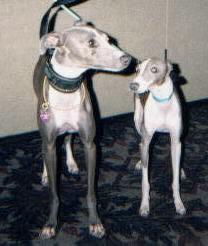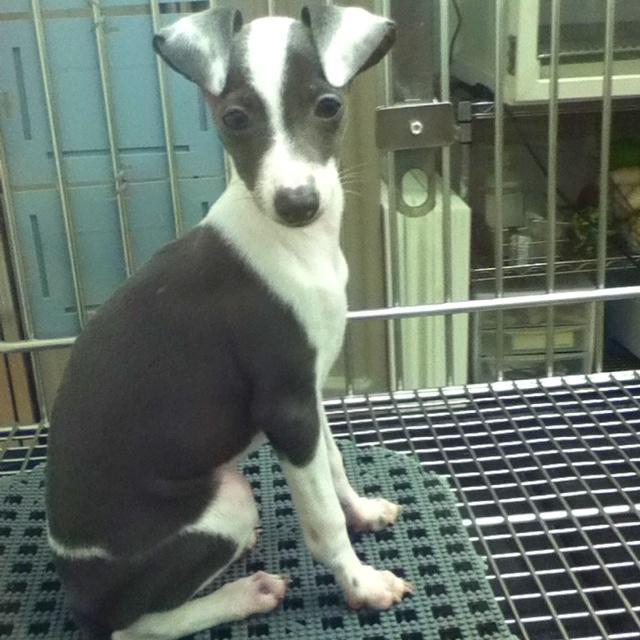The first image is the image on the left, the second image is the image on the right. For the images shown, is this caption "One image shows a dog sitting upright, and the other shows at least one dog standing on all fours." true? Answer yes or no. Yes. The first image is the image on the left, the second image is the image on the right. Assess this claim about the two images: "At least one of the dog is wearing a collar.". Correct or not? Answer yes or no. Yes. 